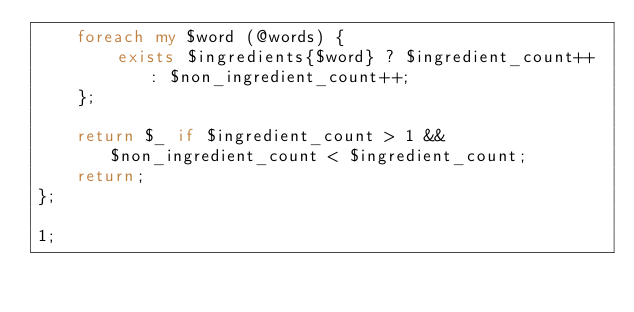<code> <loc_0><loc_0><loc_500><loc_500><_Perl_>    foreach my $word (@words) {
        exists $ingredients{$word} ? $ingredient_count++ : $non_ingredient_count++;
    };

    return $_ if $ingredient_count > 1 && $non_ingredient_count < $ingredient_count;
    return;
};

1;
</code> 